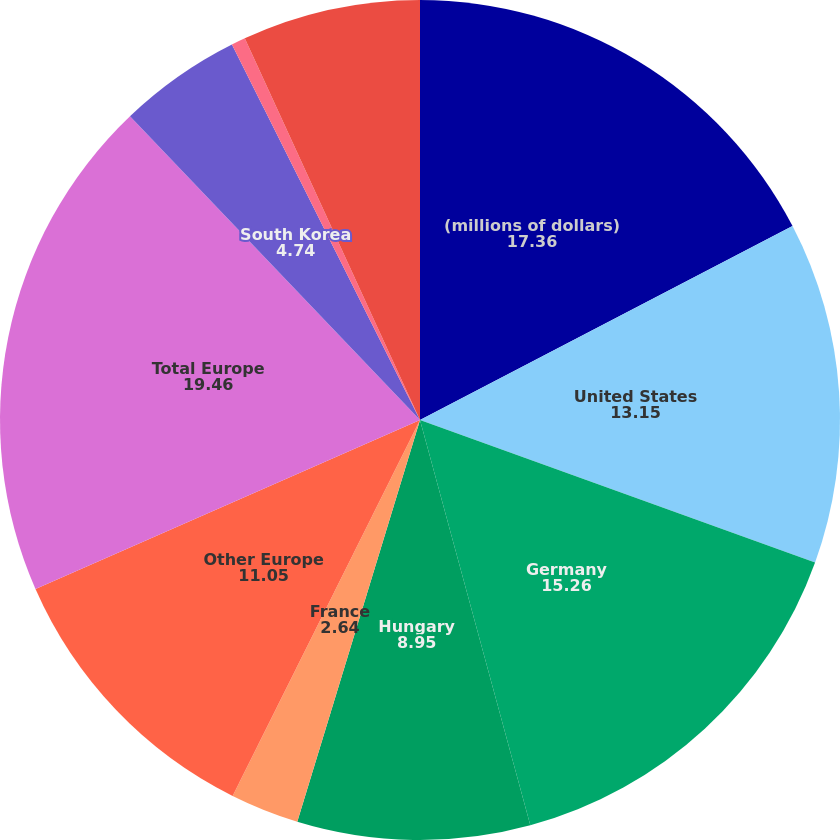<chart> <loc_0><loc_0><loc_500><loc_500><pie_chart><fcel>(millions of dollars)<fcel>United States<fcel>Germany<fcel>Hungary<fcel>France<fcel>Other Europe<fcel>Total Europe<fcel>South Korea<fcel>China<fcel>Other foreign<nl><fcel>17.36%<fcel>13.15%<fcel>15.26%<fcel>8.95%<fcel>2.64%<fcel>11.05%<fcel>19.46%<fcel>4.74%<fcel>0.54%<fcel>6.85%<nl></chart> 